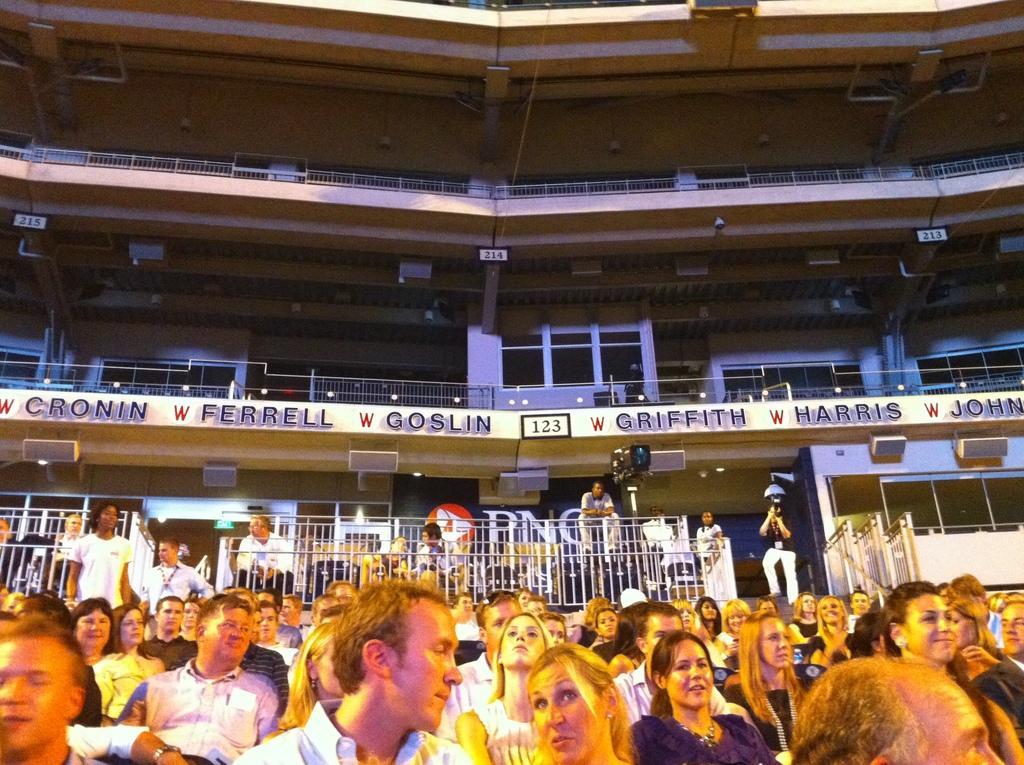In one or two sentences, can you explain what this image depicts? In this image there are railings, pillars, people, lights, boards and objects. Something is written on the boards. Among them few people are standing and one person is holding an object.   